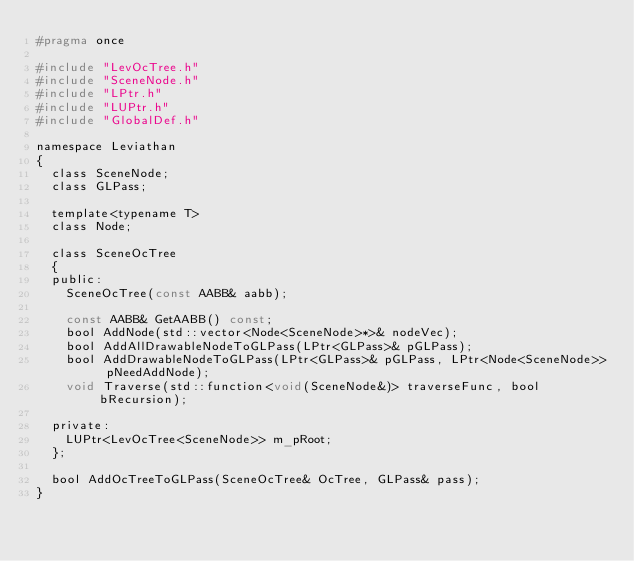Convert code to text. <code><loc_0><loc_0><loc_500><loc_500><_C_>#pragma once

#include "LevOcTree.h"
#include "SceneNode.h"
#include "LPtr.h"
#include "LUPtr.h"
#include "GlobalDef.h"

namespace Leviathan
{
	class SceneNode;
	class GLPass;

	template<typename T>
	class Node;

	class SceneOcTree
	{
	public:
		SceneOcTree(const AABB& aabb);

		const AABB& GetAABB() const;
		bool AddNode(std::vector<Node<SceneNode>*>& nodeVec);
		bool AddAllDrawableNodeToGLPass(LPtr<GLPass>& pGLPass);
		bool AddDrawableNodeToGLPass(LPtr<GLPass>& pGLPass, LPtr<Node<SceneNode>> pNeedAddNode);
		void Traverse(std::function<void(SceneNode&)> traverseFunc, bool bRecursion);

	private:
		LUPtr<LevOcTree<SceneNode>> m_pRoot;
	};

	bool AddOcTreeToGLPass(SceneOcTree& OcTree, GLPass& pass);
}</code> 